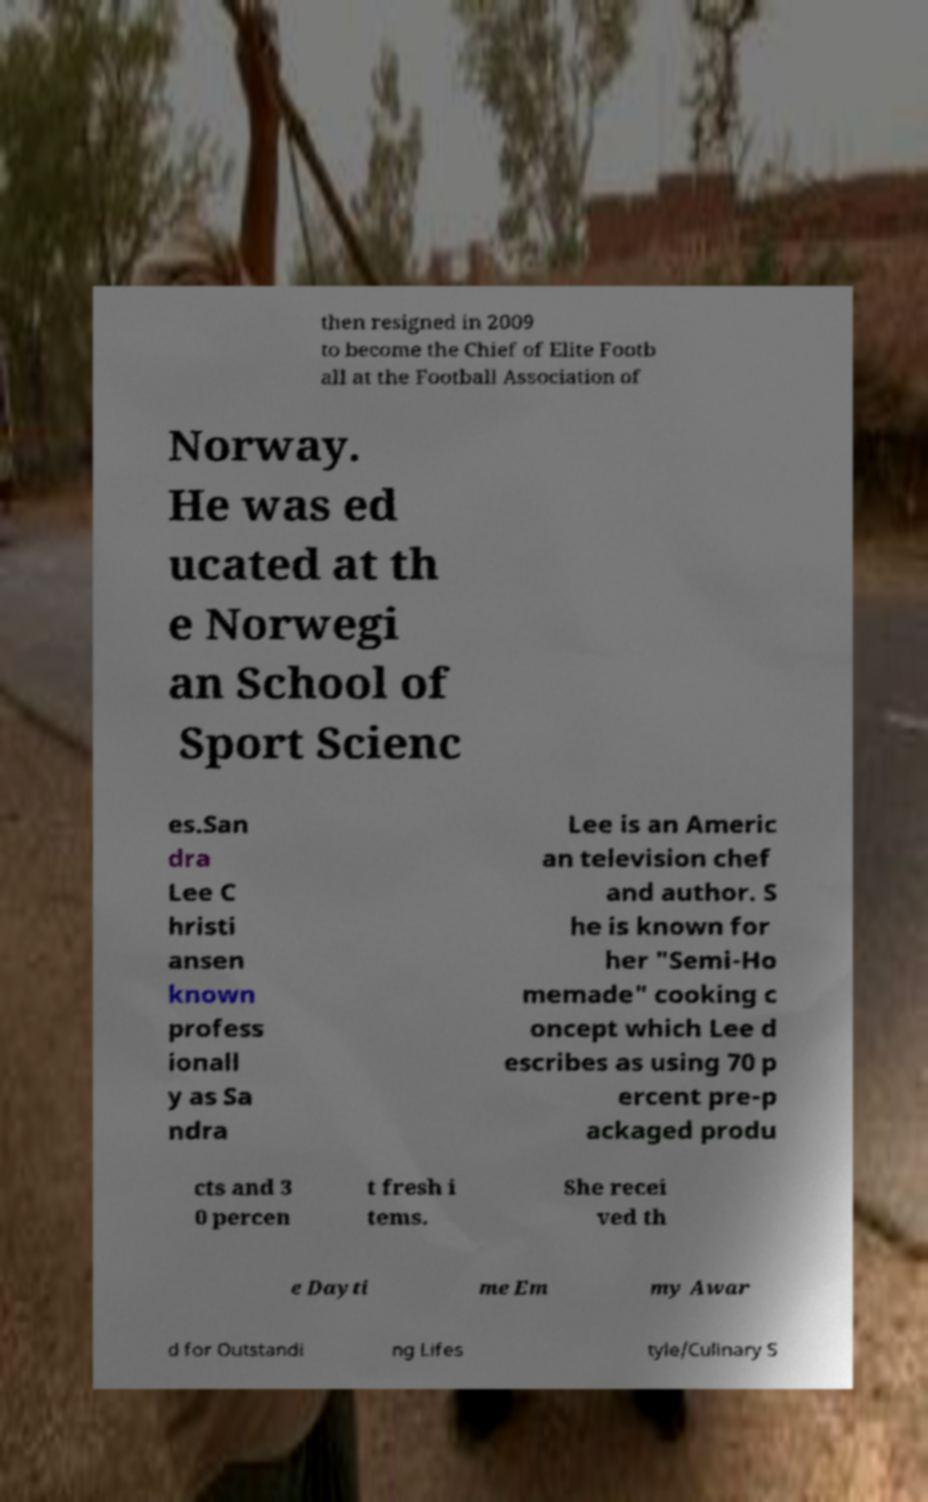I need the written content from this picture converted into text. Can you do that? then resigned in 2009 to become the Chief of Elite Footb all at the Football Association of Norway. He was ed ucated at th e Norwegi an School of Sport Scienc es.San dra Lee C hristi ansen known profess ionall y as Sa ndra Lee is an Americ an television chef and author. S he is known for her "Semi-Ho memade" cooking c oncept which Lee d escribes as using 70 p ercent pre-p ackaged produ cts and 3 0 percen t fresh i tems. She recei ved th e Dayti me Em my Awar d for Outstandi ng Lifes tyle/Culinary S 